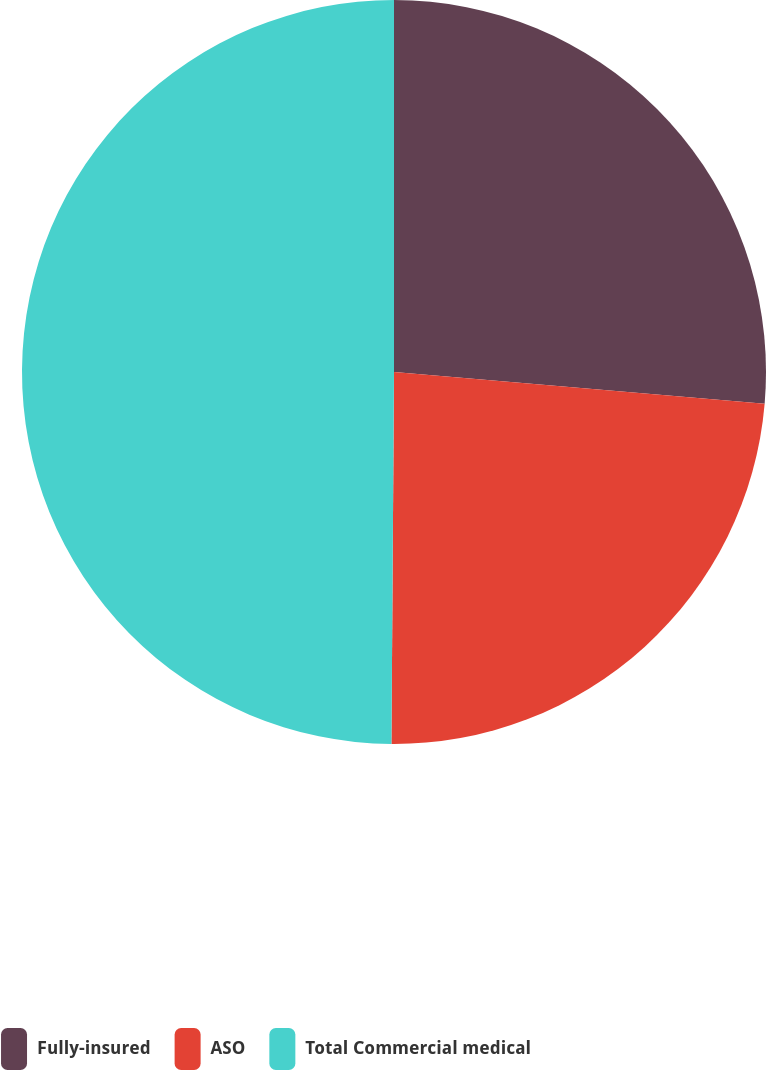Convert chart to OTSL. <chart><loc_0><loc_0><loc_500><loc_500><pie_chart><fcel>Fully-insured<fcel>ASO<fcel>Total Commercial medical<nl><fcel>26.36%<fcel>23.75%<fcel>49.89%<nl></chart> 